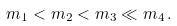<formula> <loc_0><loc_0><loc_500><loc_500>m _ { 1 } < m _ { 2 } < m _ { 3 } \ll m _ { 4 } \, .</formula> 